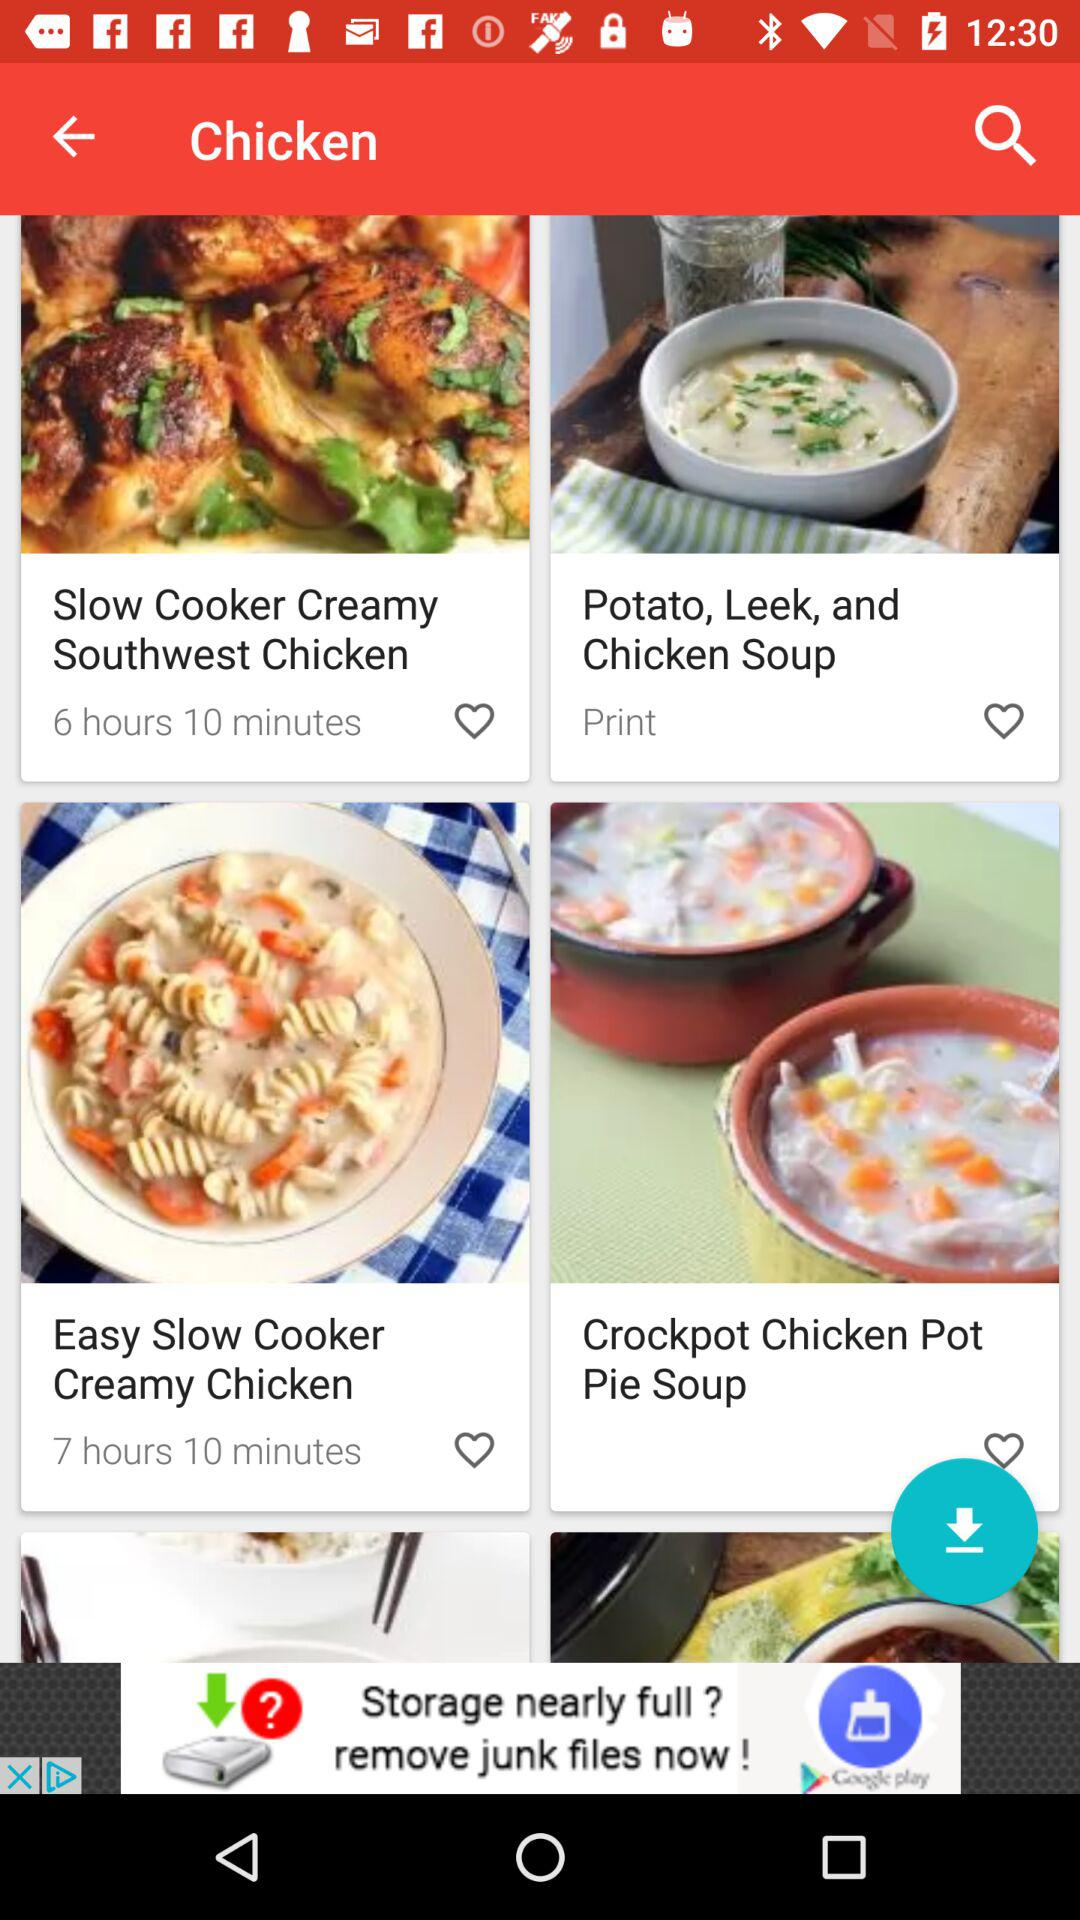What is the cooking time for "Slow Cooker Creamy Southwest Chicken"? The cooking time is 6 hours 10 minutes. 